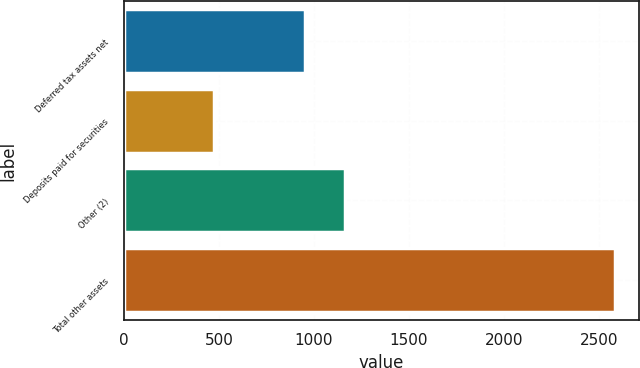Convert chart to OTSL. <chart><loc_0><loc_0><loc_500><loc_500><bar_chart><fcel>Deferred tax assets net<fcel>Deposits paid for securities<fcel>Other (2)<fcel>Total other assets<nl><fcel>951<fcel>474<fcel>1161.9<fcel>2583<nl></chart> 